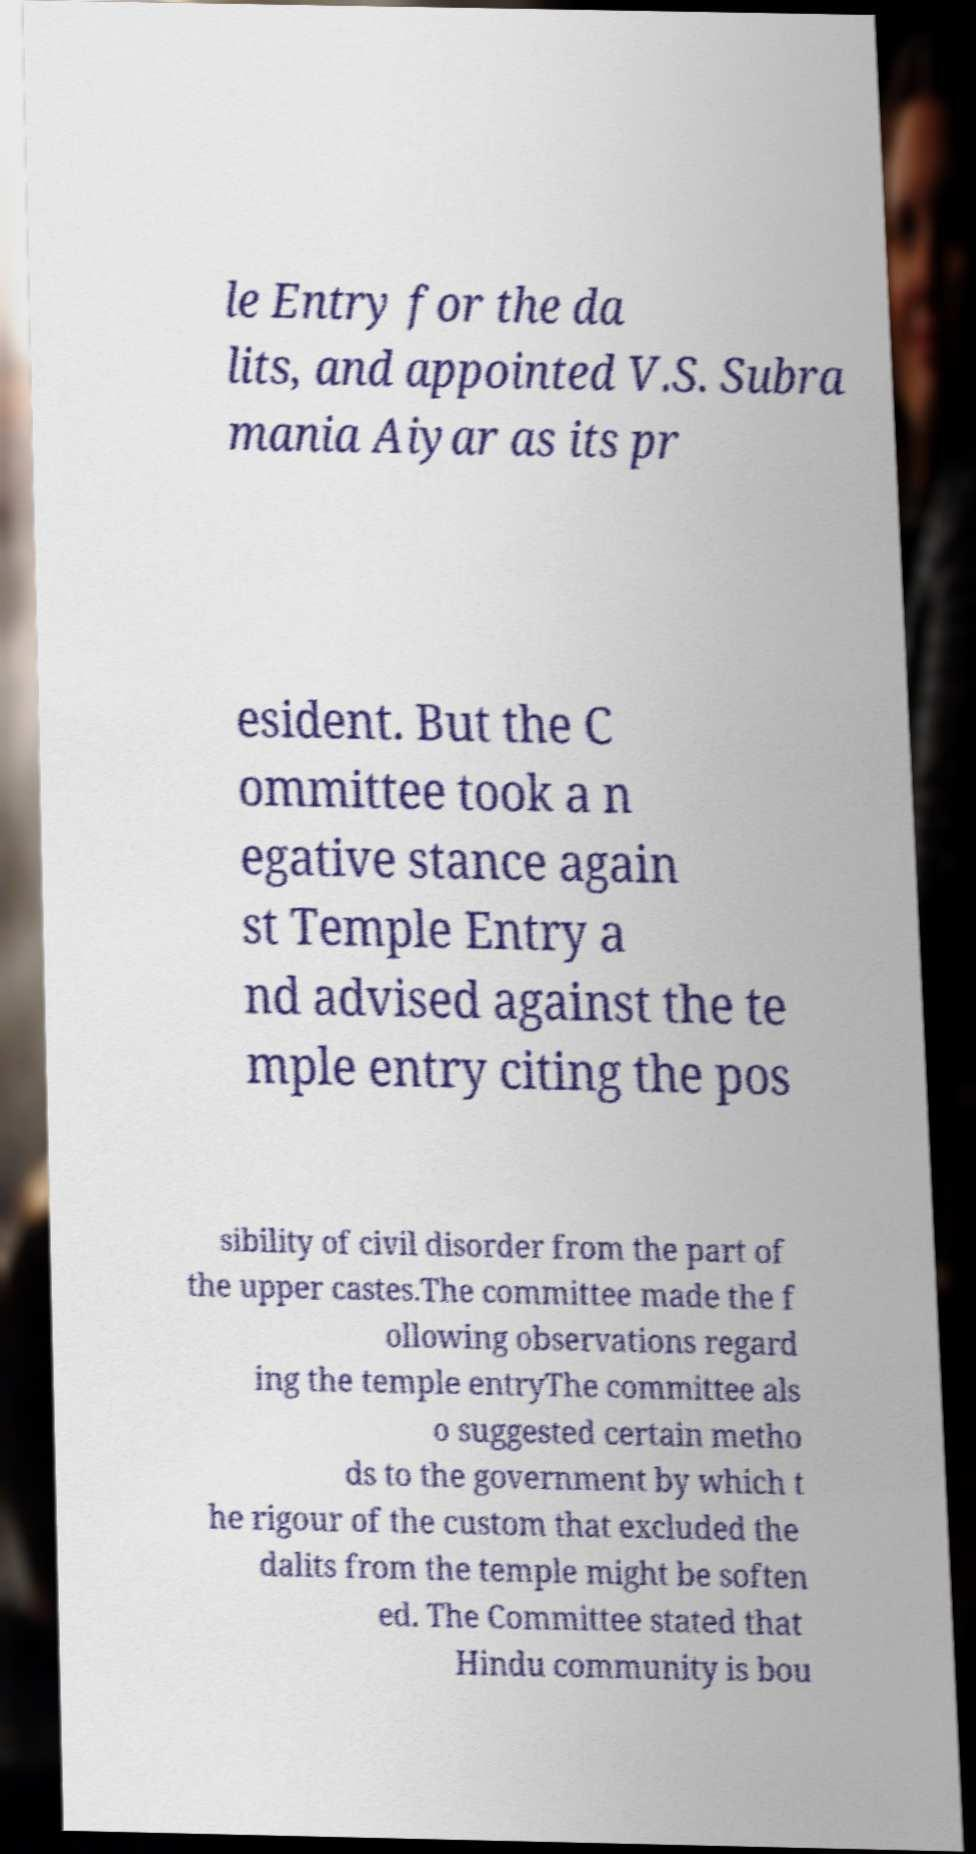What messages or text are displayed in this image? I need them in a readable, typed format. le Entry for the da lits, and appointed V.S. Subra mania Aiyar as its pr esident. But the C ommittee took a n egative stance again st Temple Entry a nd advised against the te mple entry citing the pos sibility of civil disorder from the part of the upper castes.The committee made the f ollowing observations regard ing the temple entryThe committee als o suggested certain metho ds to the government by which t he rigour of the custom that excluded the dalits from the temple might be soften ed. The Committee stated that Hindu community is bou 